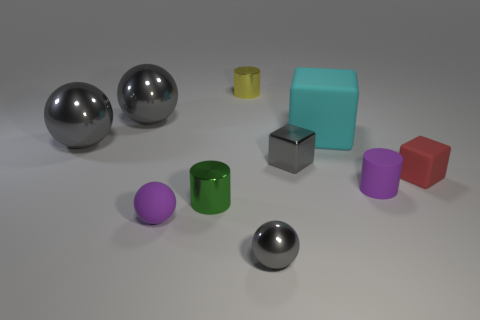How many objects are there, and can you sort them by size? In total, there are eight objects. From largest to smallest, we have a teal cube, a red cube, a grey cube, two cylindrical objects (one green, one yellow), two large silver spheres, and a small purple sphere. 